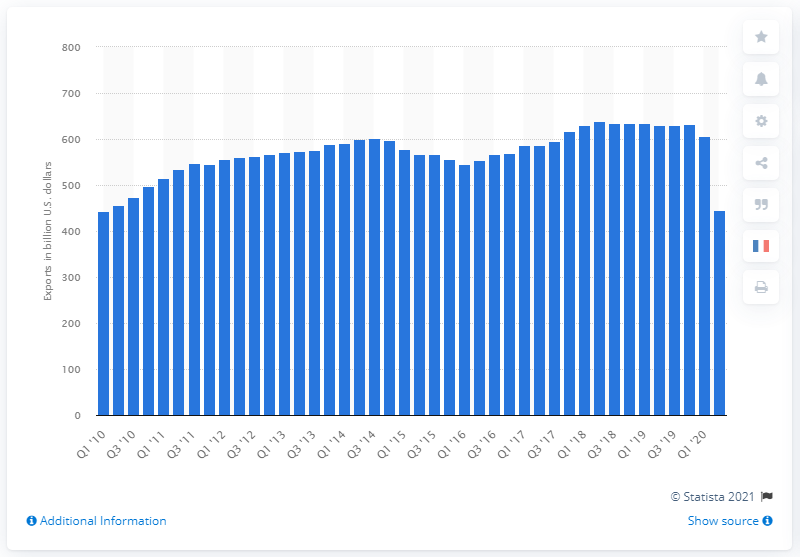Mention a couple of crucial points in this snapshot. In the second quarter of 2020, the United States exported a total of $444.65 worth of goods and services. 